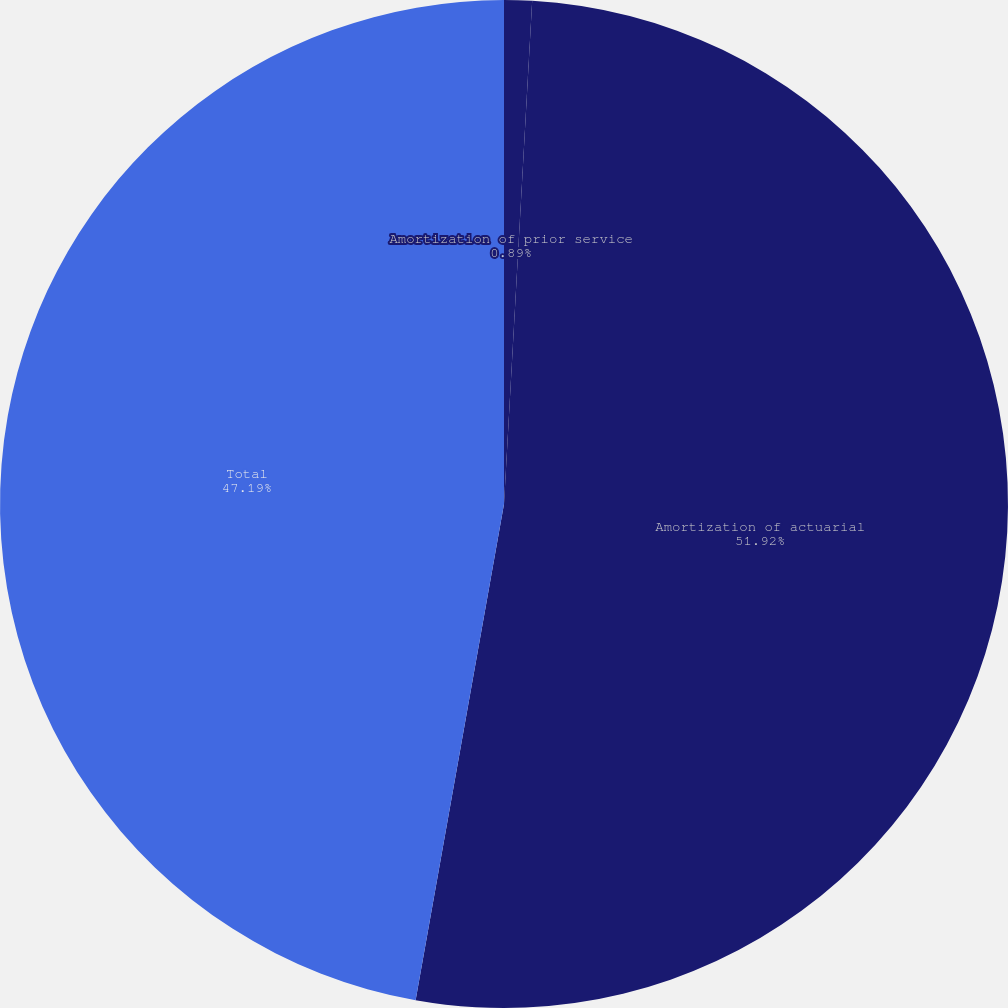Convert chart. <chart><loc_0><loc_0><loc_500><loc_500><pie_chart><fcel>Amortization of prior service<fcel>Amortization of actuarial<fcel>Total<nl><fcel>0.89%<fcel>51.91%<fcel>47.19%<nl></chart> 